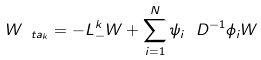<formula> <loc_0><loc_0><loc_500><loc_500>W _ { \ t a _ { k } } = - L ^ { k } _ { - } W + \sum _ { i = 1 } ^ { N } \psi _ { i } \ D ^ { - 1 } \phi _ { i } W</formula> 